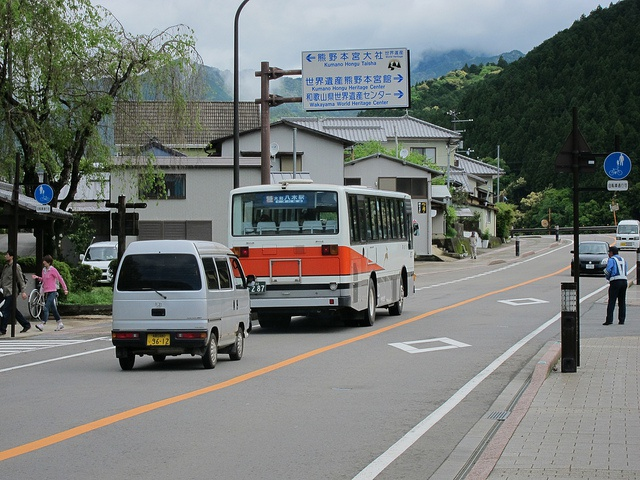Describe the objects in this image and their specific colors. I can see bus in darkgreen, black, darkgray, gray, and brown tones, car in darkgreen, black, darkgray, and gray tones, people in darkgreen, black, and gray tones, people in darkgreen, black, darkgray, blue, and gray tones, and people in darkgreen, black, violet, brown, and darkgray tones in this image. 